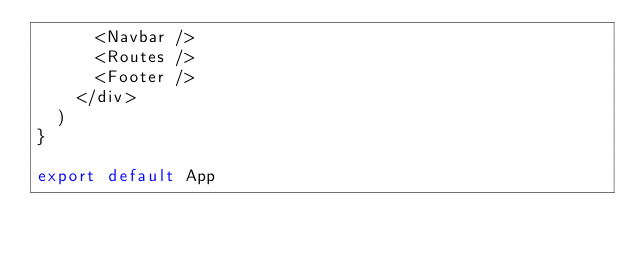<code> <loc_0><loc_0><loc_500><loc_500><_JavaScript_>      <Navbar />
      <Routes />
      <Footer />
    </div>
  )
}

export default App
</code> 